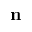Convert formula to latex. <formula><loc_0><loc_0><loc_500><loc_500>n</formula> 